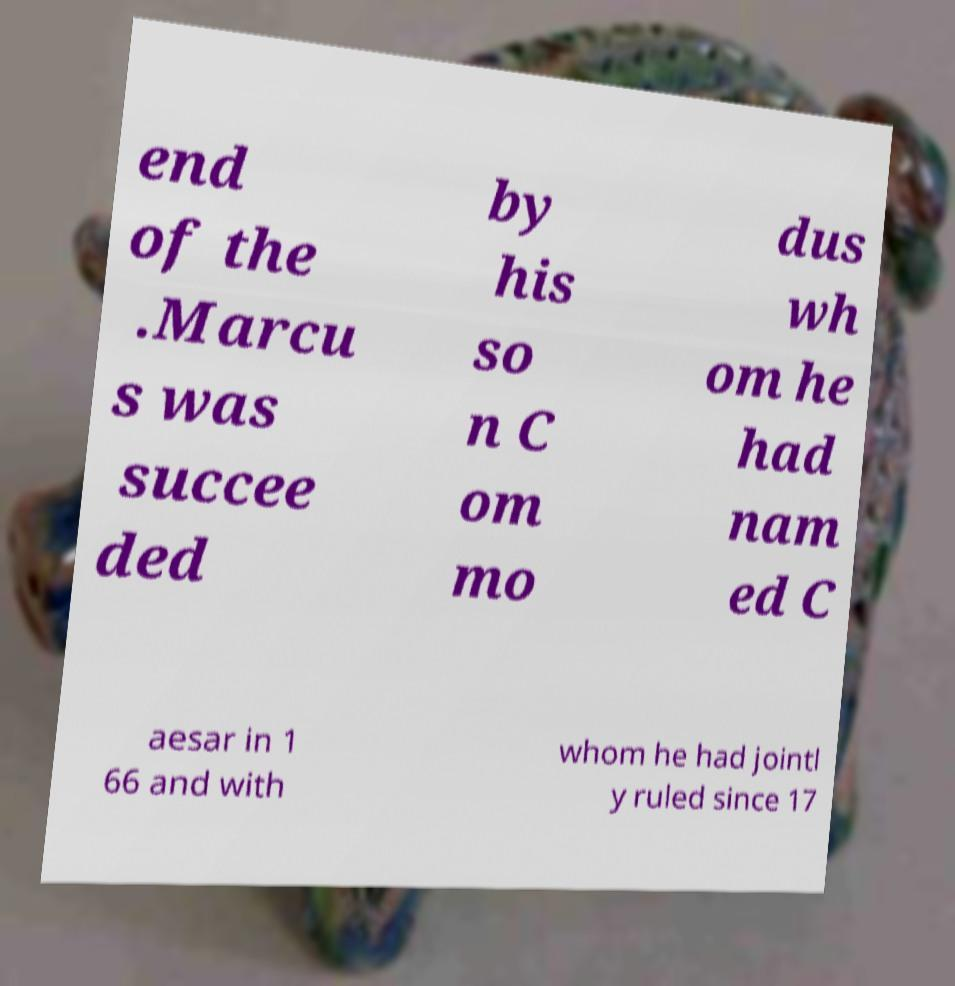For documentation purposes, I need the text within this image transcribed. Could you provide that? end of the .Marcu s was succee ded by his so n C om mo dus wh om he had nam ed C aesar in 1 66 and with whom he had jointl y ruled since 17 